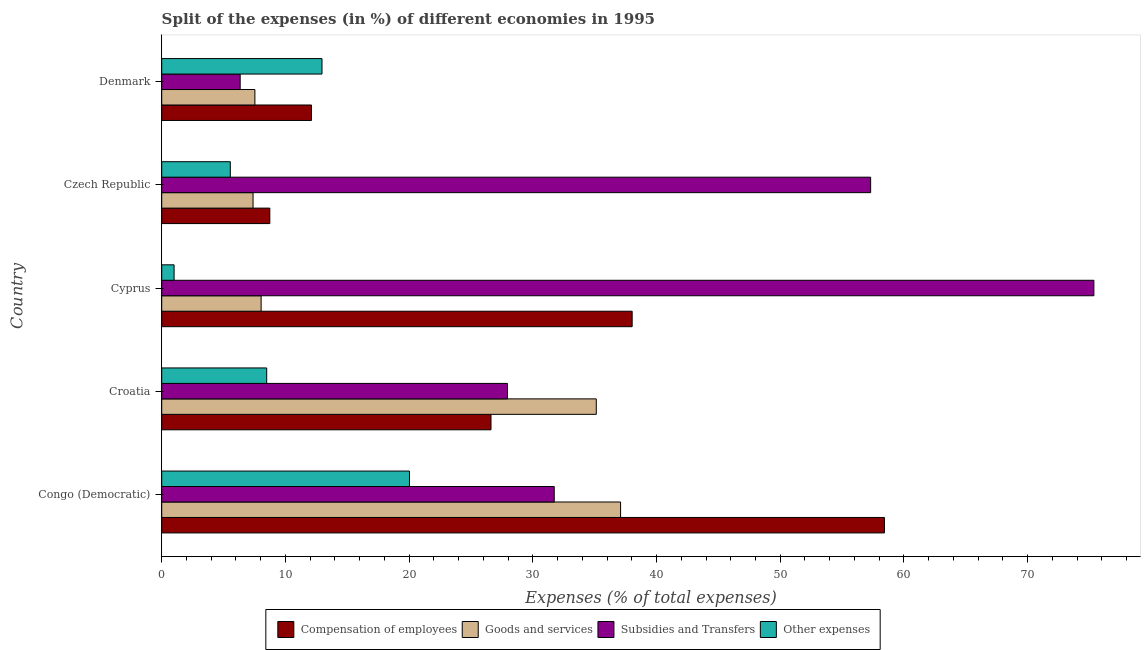How many groups of bars are there?
Your response must be concise. 5. Are the number of bars on each tick of the Y-axis equal?
Your answer should be very brief. Yes. How many bars are there on the 2nd tick from the top?
Keep it short and to the point. 4. How many bars are there on the 4th tick from the bottom?
Your answer should be compact. 4. What is the label of the 5th group of bars from the top?
Your response must be concise. Congo (Democratic). What is the percentage of amount spent on compensation of employees in Cyprus?
Provide a short and direct response. 38.03. Across all countries, what is the maximum percentage of amount spent on goods and services?
Make the answer very short. 37.09. Across all countries, what is the minimum percentage of amount spent on compensation of employees?
Give a very brief answer. 8.74. In which country was the percentage of amount spent on other expenses maximum?
Give a very brief answer. Congo (Democratic). In which country was the percentage of amount spent on subsidies minimum?
Offer a very short reply. Denmark. What is the total percentage of amount spent on goods and services in the graph?
Offer a terse response. 95.17. What is the difference between the percentage of amount spent on other expenses in Congo (Democratic) and that in Czech Republic?
Provide a succinct answer. 14.48. What is the difference between the percentage of amount spent on goods and services in Cyprus and the percentage of amount spent on other expenses in Denmark?
Give a very brief answer. -4.92. What is the average percentage of amount spent on other expenses per country?
Your response must be concise. 9.6. What is the difference between the percentage of amount spent on goods and services and percentage of amount spent on subsidies in Denmark?
Ensure brevity in your answer.  1.19. What is the ratio of the percentage of amount spent on subsidies in Cyprus to that in Czech Republic?
Offer a very short reply. 1.31. Is the percentage of amount spent on other expenses in Croatia less than that in Czech Republic?
Your answer should be very brief. No. Is the difference between the percentage of amount spent on subsidies in Congo (Democratic) and Denmark greater than the difference between the percentage of amount spent on goods and services in Congo (Democratic) and Denmark?
Give a very brief answer. No. What is the difference between the highest and the second highest percentage of amount spent on goods and services?
Provide a succinct answer. 1.97. What is the difference between the highest and the lowest percentage of amount spent on goods and services?
Ensure brevity in your answer.  29.71. In how many countries, is the percentage of amount spent on other expenses greater than the average percentage of amount spent on other expenses taken over all countries?
Make the answer very short. 2. Is the sum of the percentage of amount spent on other expenses in Croatia and Cyprus greater than the maximum percentage of amount spent on goods and services across all countries?
Provide a short and direct response. No. What does the 1st bar from the top in Czech Republic represents?
Make the answer very short. Other expenses. What does the 2nd bar from the bottom in Denmark represents?
Offer a terse response. Goods and services. Is it the case that in every country, the sum of the percentage of amount spent on compensation of employees and percentage of amount spent on goods and services is greater than the percentage of amount spent on subsidies?
Provide a short and direct response. No. How many bars are there?
Your response must be concise. 20. How many countries are there in the graph?
Provide a succinct answer. 5. What is the difference between two consecutive major ticks on the X-axis?
Keep it short and to the point. 10. Does the graph contain grids?
Keep it short and to the point. No. How many legend labels are there?
Your response must be concise. 4. How are the legend labels stacked?
Provide a short and direct response. Horizontal. What is the title of the graph?
Keep it short and to the point. Split of the expenses (in %) of different economies in 1995. What is the label or title of the X-axis?
Offer a terse response. Expenses (% of total expenses). What is the label or title of the Y-axis?
Keep it short and to the point. Country. What is the Expenses (% of total expenses) in Compensation of employees in Congo (Democratic)?
Provide a short and direct response. 58.42. What is the Expenses (% of total expenses) of Goods and services in Congo (Democratic)?
Give a very brief answer. 37.09. What is the Expenses (% of total expenses) in Subsidies and Transfers in Congo (Democratic)?
Your answer should be very brief. 31.73. What is the Expenses (% of total expenses) in Other expenses in Congo (Democratic)?
Keep it short and to the point. 20.03. What is the Expenses (% of total expenses) of Compensation of employees in Croatia?
Ensure brevity in your answer.  26.62. What is the Expenses (% of total expenses) of Goods and services in Croatia?
Your answer should be compact. 35.13. What is the Expenses (% of total expenses) of Subsidies and Transfers in Croatia?
Give a very brief answer. 27.95. What is the Expenses (% of total expenses) of Other expenses in Croatia?
Offer a very short reply. 8.49. What is the Expenses (% of total expenses) in Compensation of employees in Cyprus?
Your answer should be very brief. 38.03. What is the Expenses (% of total expenses) in Goods and services in Cyprus?
Your answer should be compact. 8.04. What is the Expenses (% of total expenses) of Subsidies and Transfers in Cyprus?
Your answer should be very brief. 75.35. What is the Expenses (% of total expenses) in Other expenses in Cyprus?
Make the answer very short. 1. What is the Expenses (% of total expenses) of Compensation of employees in Czech Republic?
Provide a short and direct response. 8.74. What is the Expenses (% of total expenses) of Goods and services in Czech Republic?
Give a very brief answer. 7.38. What is the Expenses (% of total expenses) of Subsidies and Transfers in Czech Republic?
Your answer should be compact. 57.31. What is the Expenses (% of total expenses) of Other expenses in Czech Republic?
Your answer should be compact. 5.55. What is the Expenses (% of total expenses) of Compensation of employees in Denmark?
Give a very brief answer. 12.11. What is the Expenses (% of total expenses) in Goods and services in Denmark?
Keep it short and to the point. 7.53. What is the Expenses (% of total expenses) in Subsidies and Transfers in Denmark?
Offer a terse response. 6.34. What is the Expenses (% of total expenses) in Other expenses in Denmark?
Give a very brief answer. 12.96. Across all countries, what is the maximum Expenses (% of total expenses) in Compensation of employees?
Give a very brief answer. 58.42. Across all countries, what is the maximum Expenses (% of total expenses) of Goods and services?
Offer a very short reply. 37.09. Across all countries, what is the maximum Expenses (% of total expenses) of Subsidies and Transfers?
Your answer should be very brief. 75.35. Across all countries, what is the maximum Expenses (% of total expenses) in Other expenses?
Offer a terse response. 20.03. Across all countries, what is the minimum Expenses (% of total expenses) in Compensation of employees?
Offer a very short reply. 8.74. Across all countries, what is the minimum Expenses (% of total expenses) in Goods and services?
Provide a succinct answer. 7.38. Across all countries, what is the minimum Expenses (% of total expenses) of Subsidies and Transfers?
Offer a terse response. 6.34. Across all countries, what is the minimum Expenses (% of total expenses) of Other expenses?
Your response must be concise. 1. What is the total Expenses (% of total expenses) of Compensation of employees in the graph?
Your answer should be very brief. 143.91. What is the total Expenses (% of total expenses) of Goods and services in the graph?
Ensure brevity in your answer.  95.17. What is the total Expenses (% of total expenses) in Subsidies and Transfers in the graph?
Your answer should be compact. 198.68. What is the total Expenses (% of total expenses) of Other expenses in the graph?
Give a very brief answer. 48.02. What is the difference between the Expenses (% of total expenses) in Compensation of employees in Congo (Democratic) and that in Croatia?
Offer a very short reply. 31.8. What is the difference between the Expenses (% of total expenses) of Goods and services in Congo (Democratic) and that in Croatia?
Make the answer very short. 1.96. What is the difference between the Expenses (% of total expenses) in Subsidies and Transfers in Congo (Democratic) and that in Croatia?
Make the answer very short. 3.78. What is the difference between the Expenses (% of total expenses) in Other expenses in Congo (Democratic) and that in Croatia?
Keep it short and to the point. 11.54. What is the difference between the Expenses (% of total expenses) in Compensation of employees in Congo (Democratic) and that in Cyprus?
Provide a short and direct response. 20.39. What is the difference between the Expenses (% of total expenses) of Goods and services in Congo (Democratic) and that in Cyprus?
Provide a succinct answer. 29.06. What is the difference between the Expenses (% of total expenses) of Subsidies and Transfers in Congo (Democratic) and that in Cyprus?
Your response must be concise. -43.62. What is the difference between the Expenses (% of total expenses) in Other expenses in Congo (Democratic) and that in Cyprus?
Provide a succinct answer. 19.03. What is the difference between the Expenses (% of total expenses) of Compensation of employees in Congo (Democratic) and that in Czech Republic?
Make the answer very short. 49.68. What is the difference between the Expenses (% of total expenses) of Goods and services in Congo (Democratic) and that in Czech Republic?
Make the answer very short. 29.71. What is the difference between the Expenses (% of total expenses) in Subsidies and Transfers in Congo (Democratic) and that in Czech Republic?
Your answer should be very brief. -25.58. What is the difference between the Expenses (% of total expenses) in Other expenses in Congo (Democratic) and that in Czech Republic?
Your answer should be very brief. 14.48. What is the difference between the Expenses (% of total expenses) in Compensation of employees in Congo (Democratic) and that in Denmark?
Provide a succinct answer. 46.31. What is the difference between the Expenses (% of total expenses) of Goods and services in Congo (Democratic) and that in Denmark?
Keep it short and to the point. 29.56. What is the difference between the Expenses (% of total expenses) in Subsidies and Transfers in Congo (Democratic) and that in Denmark?
Ensure brevity in your answer.  25.39. What is the difference between the Expenses (% of total expenses) in Other expenses in Congo (Democratic) and that in Denmark?
Your answer should be very brief. 7.07. What is the difference between the Expenses (% of total expenses) of Compensation of employees in Croatia and that in Cyprus?
Provide a short and direct response. -11.41. What is the difference between the Expenses (% of total expenses) of Goods and services in Croatia and that in Cyprus?
Your answer should be compact. 27.09. What is the difference between the Expenses (% of total expenses) of Subsidies and Transfers in Croatia and that in Cyprus?
Provide a short and direct response. -47.41. What is the difference between the Expenses (% of total expenses) in Other expenses in Croatia and that in Cyprus?
Provide a short and direct response. 7.49. What is the difference between the Expenses (% of total expenses) of Compensation of employees in Croatia and that in Czech Republic?
Keep it short and to the point. 17.88. What is the difference between the Expenses (% of total expenses) in Goods and services in Croatia and that in Czech Republic?
Offer a very short reply. 27.74. What is the difference between the Expenses (% of total expenses) in Subsidies and Transfers in Croatia and that in Czech Republic?
Provide a succinct answer. -29.36. What is the difference between the Expenses (% of total expenses) of Other expenses in Croatia and that in Czech Republic?
Provide a short and direct response. 2.94. What is the difference between the Expenses (% of total expenses) of Compensation of employees in Croatia and that in Denmark?
Offer a very short reply. 14.51. What is the difference between the Expenses (% of total expenses) in Goods and services in Croatia and that in Denmark?
Provide a short and direct response. 27.6. What is the difference between the Expenses (% of total expenses) of Subsidies and Transfers in Croatia and that in Denmark?
Offer a terse response. 21.61. What is the difference between the Expenses (% of total expenses) in Other expenses in Croatia and that in Denmark?
Give a very brief answer. -4.47. What is the difference between the Expenses (% of total expenses) of Compensation of employees in Cyprus and that in Czech Republic?
Your answer should be compact. 29.29. What is the difference between the Expenses (% of total expenses) of Goods and services in Cyprus and that in Czech Republic?
Provide a succinct answer. 0.65. What is the difference between the Expenses (% of total expenses) in Subsidies and Transfers in Cyprus and that in Czech Republic?
Offer a very short reply. 18.05. What is the difference between the Expenses (% of total expenses) of Other expenses in Cyprus and that in Czech Republic?
Give a very brief answer. -4.54. What is the difference between the Expenses (% of total expenses) in Compensation of employees in Cyprus and that in Denmark?
Your answer should be very brief. 25.92. What is the difference between the Expenses (% of total expenses) in Goods and services in Cyprus and that in Denmark?
Give a very brief answer. 0.5. What is the difference between the Expenses (% of total expenses) in Subsidies and Transfers in Cyprus and that in Denmark?
Make the answer very short. 69.01. What is the difference between the Expenses (% of total expenses) of Other expenses in Cyprus and that in Denmark?
Provide a succinct answer. -11.96. What is the difference between the Expenses (% of total expenses) of Compensation of employees in Czech Republic and that in Denmark?
Ensure brevity in your answer.  -3.37. What is the difference between the Expenses (% of total expenses) in Goods and services in Czech Republic and that in Denmark?
Your answer should be compact. -0.15. What is the difference between the Expenses (% of total expenses) of Subsidies and Transfers in Czech Republic and that in Denmark?
Give a very brief answer. 50.97. What is the difference between the Expenses (% of total expenses) of Other expenses in Czech Republic and that in Denmark?
Make the answer very short. -7.41. What is the difference between the Expenses (% of total expenses) of Compensation of employees in Congo (Democratic) and the Expenses (% of total expenses) of Goods and services in Croatia?
Offer a very short reply. 23.29. What is the difference between the Expenses (% of total expenses) of Compensation of employees in Congo (Democratic) and the Expenses (% of total expenses) of Subsidies and Transfers in Croatia?
Keep it short and to the point. 30.47. What is the difference between the Expenses (% of total expenses) in Compensation of employees in Congo (Democratic) and the Expenses (% of total expenses) in Other expenses in Croatia?
Your response must be concise. 49.93. What is the difference between the Expenses (% of total expenses) in Goods and services in Congo (Democratic) and the Expenses (% of total expenses) in Subsidies and Transfers in Croatia?
Provide a short and direct response. 9.14. What is the difference between the Expenses (% of total expenses) of Goods and services in Congo (Democratic) and the Expenses (% of total expenses) of Other expenses in Croatia?
Make the answer very short. 28.61. What is the difference between the Expenses (% of total expenses) of Subsidies and Transfers in Congo (Democratic) and the Expenses (% of total expenses) of Other expenses in Croatia?
Provide a short and direct response. 23.24. What is the difference between the Expenses (% of total expenses) in Compensation of employees in Congo (Democratic) and the Expenses (% of total expenses) in Goods and services in Cyprus?
Offer a very short reply. 50.38. What is the difference between the Expenses (% of total expenses) in Compensation of employees in Congo (Democratic) and the Expenses (% of total expenses) in Subsidies and Transfers in Cyprus?
Make the answer very short. -16.93. What is the difference between the Expenses (% of total expenses) of Compensation of employees in Congo (Democratic) and the Expenses (% of total expenses) of Other expenses in Cyprus?
Your response must be concise. 57.42. What is the difference between the Expenses (% of total expenses) of Goods and services in Congo (Democratic) and the Expenses (% of total expenses) of Subsidies and Transfers in Cyprus?
Provide a succinct answer. -38.26. What is the difference between the Expenses (% of total expenses) of Goods and services in Congo (Democratic) and the Expenses (% of total expenses) of Other expenses in Cyprus?
Give a very brief answer. 36.09. What is the difference between the Expenses (% of total expenses) in Subsidies and Transfers in Congo (Democratic) and the Expenses (% of total expenses) in Other expenses in Cyprus?
Provide a short and direct response. 30.73. What is the difference between the Expenses (% of total expenses) in Compensation of employees in Congo (Democratic) and the Expenses (% of total expenses) in Goods and services in Czech Republic?
Provide a succinct answer. 51.04. What is the difference between the Expenses (% of total expenses) of Compensation of employees in Congo (Democratic) and the Expenses (% of total expenses) of Subsidies and Transfers in Czech Republic?
Keep it short and to the point. 1.11. What is the difference between the Expenses (% of total expenses) in Compensation of employees in Congo (Democratic) and the Expenses (% of total expenses) in Other expenses in Czech Republic?
Your response must be concise. 52.87. What is the difference between the Expenses (% of total expenses) in Goods and services in Congo (Democratic) and the Expenses (% of total expenses) in Subsidies and Transfers in Czech Republic?
Offer a very short reply. -20.21. What is the difference between the Expenses (% of total expenses) in Goods and services in Congo (Democratic) and the Expenses (% of total expenses) in Other expenses in Czech Republic?
Provide a succinct answer. 31.55. What is the difference between the Expenses (% of total expenses) of Subsidies and Transfers in Congo (Democratic) and the Expenses (% of total expenses) of Other expenses in Czech Republic?
Offer a terse response. 26.18. What is the difference between the Expenses (% of total expenses) of Compensation of employees in Congo (Democratic) and the Expenses (% of total expenses) of Goods and services in Denmark?
Provide a short and direct response. 50.89. What is the difference between the Expenses (% of total expenses) of Compensation of employees in Congo (Democratic) and the Expenses (% of total expenses) of Subsidies and Transfers in Denmark?
Keep it short and to the point. 52.08. What is the difference between the Expenses (% of total expenses) of Compensation of employees in Congo (Democratic) and the Expenses (% of total expenses) of Other expenses in Denmark?
Your response must be concise. 45.46. What is the difference between the Expenses (% of total expenses) in Goods and services in Congo (Democratic) and the Expenses (% of total expenses) in Subsidies and Transfers in Denmark?
Your answer should be very brief. 30.75. What is the difference between the Expenses (% of total expenses) in Goods and services in Congo (Democratic) and the Expenses (% of total expenses) in Other expenses in Denmark?
Ensure brevity in your answer.  24.14. What is the difference between the Expenses (% of total expenses) in Subsidies and Transfers in Congo (Democratic) and the Expenses (% of total expenses) in Other expenses in Denmark?
Give a very brief answer. 18.77. What is the difference between the Expenses (% of total expenses) in Compensation of employees in Croatia and the Expenses (% of total expenses) in Goods and services in Cyprus?
Make the answer very short. 18.58. What is the difference between the Expenses (% of total expenses) in Compensation of employees in Croatia and the Expenses (% of total expenses) in Subsidies and Transfers in Cyprus?
Offer a terse response. -48.73. What is the difference between the Expenses (% of total expenses) of Compensation of employees in Croatia and the Expenses (% of total expenses) of Other expenses in Cyprus?
Keep it short and to the point. 25.62. What is the difference between the Expenses (% of total expenses) of Goods and services in Croatia and the Expenses (% of total expenses) of Subsidies and Transfers in Cyprus?
Provide a short and direct response. -40.22. What is the difference between the Expenses (% of total expenses) of Goods and services in Croatia and the Expenses (% of total expenses) of Other expenses in Cyprus?
Provide a short and direct response. 34.13. What is the difference between the Expenses (% of total expenses) of Subsidies and Transfers in Croatia and the Expenses (% of total expenses) of Other expenses in Cyprus?
Your answer should be very brief. 26.95. What is the difference between the Expenses (% of total expenses) of Compensation of employees in Croatia and the Expenses (% of total expenses) of Goods and services in Czech Republic?
Provide a short and direct response. 19.23. What is the difference between the Expenses (% of total expenses) of Compensation of employees in Croatia and the Expenses (% of total expenses) of Subsidies and Transfers in Czech Republic?
Ensure brevity in your answer.  -30.69. What is the difference between the Expenses (% of total expenses) in Compensation of employees in Croatia and the Expenses (% of total expenses) in Other expenses in Czech Republic?
Make the answer very short. 21.07. What is the difference between the Expenses (% of total expenses) in Goods and services in Croatia and the Expenses (% of total expenses) in Subsidies and Transfers in Czech Republic?
Provide a short and direct response. -22.18. What is the difference between the Expenses (% of total expenses) of Goods and services in Croatia and the Expenses (% of total expenses) of Other expenses in Czech Republic?
Your answer should be compact. 29.58. What is the difference between the Expenses (% of total expenses) of Subsidies and Transfers in Croatia and the Expenses (% of total expenses) of Other expenses in Czech Republic?
Provide a short and direct response. 22.4. What is the difference between the Expenses (% of total expenses) in Compensation of employees in Croatia and the Expenses (% of total expenses) in Goods and services in Denmark?
Make the answer very short. 19.09. What is the difference between the Expenses (% of total expenses) of Compensation of employees in Croatia and the Expenses (% of total expenses) of Subsidies and Transfers in Denmark?
Provide a succinct answer. 20.28. What is the difference between the Expenses (% of total expenses) of Compensation of employees in Croatia and the Expenses (% of total expenses) of Other expenses in Denmark?
Your answer should be compact. 13.66. What is the difference between the Expenses (% of total expenses) of Goods and services in Croatia and the Expenses (% of total expenses) of Subsidies and Transfers in Denmark?
Offer a very short reply. 28.79. What is the difference between the Expenses (% of total expenses) of Goods and services in Croatia and the Expenses (% of total expenses) of Other expenses in Denmark?
Offer a very short reply. 22.17. What is the difference between the Expenses (% of total expenses) in Subsidies and Transfers in Croatia and the Expenses (% of total expenses) in Other expenses in Denmark?
Provide a short and direct response. 14.99. What is the difference between the Expenses (% of total expenses) of Compensation of employees in Cyprus and the Expenses (% of total expenses) of Goods and services in Czech Republic?
Provide a short and direct response. 30.65. What is the difference between the Expenses (% of total expenses) in Compensation of employees in Cyprus and the Expenses (% of total expenses) in Subsidies and Transfers in Czech Republic?
Your answer should be compact. -19.28. What is the difference between the Expenses (% of total expenses) of Compensation of employees in Cyprus and the Expenses (% of total expenses) of Other expenses in Czech Republic?
Keep it short and to the point. 32.48. What is the difference between the Expenses (% of total expenses) of Goods and services in Cyprus and the Expenses (% of total expenses) of Subsidies and Transfers in Czech Republic?
Your answer should be very brief. -49.27. What is the difference between the Expenses (% of total expenses) of Goods and services in Cyprus and the Expenses (% of total expenses) of Other expenses in Czech Republic?
Your answer should be very brief. 2.49. What is the difference between the Expenses (% of total expenses) in Subsidies and Transfers in Cyprus and the Expenses (% of total expenses) in Other expenses in Czech Republic?
Provide a succinct answer. 69.81. What is the difference between the Expenses (% of total expenses) in Compensation of employees in Cyprus and the Expenses (% of total expenses) in Goods and services in Denmark?
Your answer should be compact. 30.5. What is the difference between the Expenses (% of total expenses) of Compensation of employees in Cyprus and the Expenses (% of total expenses) of Subsidies and Transfers in Denmark?
Give a very brief answer. 31.69. What is the difference between the Expenses (% of total expenses) of Compensation of employees in Cyprus and the Expenses (% of total expenses) of Other expenses in Denmark?
Give a very brief answer. 25.07. What is the difference between the Expenses (% of total expenses) in Goods and services in Cyprus and the Expenses (% of total expenses) in Subsidies and Transfers in Denmark?
Offer a very short reply. 1.69. What is the difference between the Expenses (% of total expenses) of Goods and services in Cyprus and the Expenses (% of total expenses) of Other expenses in Denmark?
Your answer should be compact. -4.92. What is the difference between the Expenses (% of total expenses) of Subsidies and Transfers in Cyprus and the Expenses (% of total expenses) of Other expenses in Denmark?
Your answer should be compact. 62.4. What is the difference between the Expenses (% of total expenses) of Compensation of employees in Czech Republic and the Expenses (% of total expenses) of Goods and services in Denmark?
Give a very brief answer. 1.21. What is the difference between the Expenses (% of total expenses) in Compensation of employees in Czech Republic and the Expenses (% of total expenses) in Subsidies and Transfers in Denmark?
Your response must be concise. 2.4. What is the difference between the Expenses (% of total expenses) in Compensation of employees in Czech Republic and the Expenses (% of total expenses) in Other expenses in Denmark?
Offer a very short reply. -4.22. What is the difference between the Expenses (% of total expenses) of Goods and services in Czech Republic and the Expenses (% of total expenses) of Subsidies and Transfers in Denmark?
Offer a very short reply. 1.04. What is the difference between the Expenses (% of total expenses) in Goods and services in Czech Republic and the Expenses (% of total expenses) in Other expenses in Denmark?
Provide a succinct answer. -5.57. What is the difference between the Expenses (% of total expenses) of Subsidies and Transfers in Czech Republic and the Expenses (% of total expenses) of Other expenses in Denmark?
Offer a very short reply. 44.35. What is the average Expenses (% of total expenses) in Compensation of employees per country?
Make the answer very short. 28.78. What is the average Expenses (% of total expenses) in Goods and services per country?
Give a very brief answer. 19.03. What is the average Expenses (% of total expenses) of Subsidies and Transfers per country?
Ensure brevity in your answer.  39.74. What is the average Expenses (% of total expenses) of Other expenses per country?
Offer a very short reply. 9.6. What is the difference between the Expenses (% of total expenses) of Compensation of employees and Expenses (% of total expenses) of Goods and services in Congo (Democratic)?
Your response must be concise. 21.33. What is the difference between the Expenses (% of total expenses) of Compensation of employees and Expenses (% of total expenses) of Subsidies and Transfers in Congo (Democratic)?
Give a very brief answer. 26.69. What is the difference between the Expenses (% of total expenses) in Compensation of employees and Expenses (% of total expenses) in Other expenses in Congo (Democratic)?
Provide a succinct answer. 38.39. What is the difference between the Expenses (% of total expenses) in Goods and services and Expenses (% of total expenses) in Subsidies and Transfers in Congo (Democratic)?
Give a very brief answer. 5.36. What is the difference between the Expenses (% of total expenses) of Goods and services and Expenses (% of total expenses) of Other expenses in Congo (Democratic)?
Offer a terse response. 17.07. What is the difference between the Expenses (% of total expenses) of Subsidies and Transfers and Expenses (% of total expenses) of Other expenses in Congo (Democratic)?
Provide a short and direct response. 11.7. What is the difference between the Expenses (% of total expenses) in Compensation of employees and Expenses (% of total expenses) in Goods and services in Croatia?
Provide a short and direct response. -8.51. What is the difference between the Expenses (% of total expenses) in Compensation of employees and Expenses (% of total expenses) in Subsidies and Transfers in Croatia?
Ensure brevity in your answer.  -1.33. What is the difference between the Expenses (% of total expenses) in Compensation of employees and Expenses (% of total expenses) in Other expenses in Croatia?
Keep it short and to the point. 18.13. What is the difference between the Expenses (% of total expenses) of Goods and services and Expenses (% of total expenses) of Subsidies and Transfers in Croatia?
Provide a succinct answer. 7.18. What is the difference between the Expenses (% of total expenses) of Goods and services and Expenses (% of total expenses) of Other expenses in Croatia?
Provide a short and direct response. 26.64. What is the difference between the Expenses (% of total expenses) of Subsidies and Transfers and Expenses (% of total expenses) of Other expenses in Croatia?
Your answer should be compact. 19.46. What is the difference between the Expenses (% of total expenses) of Compensation of employees and Expenses (% of total expenses) of Goods and services in Cyprus?
Provide a succinct answer. 29.99. What is the difference between the Expenses (% of total expenses) in Compensation of employees and Expenses (% of total expenses) in Subsidies and Transfers in Cyprus?
Offer a terse response. -37.32. What is the difference between the Expenses (% of total expenses) of Compensation of employees and Expenses (% of total expenses) of Other expenses in Cyprus?
Give a very brief answer. 37.03. What is the difference between the Expenses (% of total expenses) of Goods and services and Expenses (% of total expenses) of Subsidies and Transfers in Cyprus?
Give a very brief answer. -67.32. What is the difference between the Expenses (% of total expenses) of Goods and services and Expenses (% of total expenses) of Other expenses in Cyprus?
Your answer should be compact. 7.03. What is the difference between the Expenses (% of total expenses) of Subsidies and Transfers and Expenses (% of total expenses) of Other expenses in Cyprus?
Keep it short and to the point. 74.35. What is the difference between the Expenses (% of total expenses) in Compensation of employees and Expenses (% of total expenses) in Goods and services in Czech Republic?
Your answer should be very brief. 1.35. What is the difference between the Expenses (% of total expenses) of Compensation of employees and Expenses (% of total expenses) of Subsidies and Transfers in Czech Republic?
Your response must be concise. -48.57. What is the difference between the Expenses (% of total expenses) of Compensation of employees and Expenses (% of total expenses) of Other expenses in Czech Republic?
Provide a succinct answer. 3.19. What is the difference between the Expenses (% of total expenses) in Goods and services and Expenses (% of total expenses) in Subsidies and Transfers in Czech Republic?
Offer a terse response. -49.92. What is the difference between the Expenses (% of total expenses) in Goods and services and Expenses (% of total expenses) in Other expenses in Czech Republic?
Provide a succinct answer. 1.84. What is the difference between the Expenses (% of total expenses) of Subsidies and Transfers and Expenses (% of total expenses) of Other expenses in Czech Republic?
Your answer should be compact. 51.76. What is the difference between the Expenses (% of total expenses) of Compensation of employees and Expenses (% of total expenses) of Goods and services in Denmark?
Provide a succinct answer. 4.58. What is the difference between the Expenses (% of total expenses) of Compensation of employees and Expenses (% of total expenses) of Subsidies and Transfers in Denmark?
Offer a very short reply. 5.76. What is the difference between the Expenses (% of total expenses) in Compensation of employees and Expenses (% of total expenses) in Other expenses in Denmark?
Your answer should be very brief. -0.85. What is the difference between the Expenses (% of total expenses) of Goods and services and Expenses (% of total expenses) of Subsidies and Transfers in Denmark?
Provide a succinct answer. 1.19. What is the difference between the Expenses (% of total expenses) in Goods and services and Expenses (% of total expenses) in Other expenses in Denmark?
Provide a short and direct response. -5.43. What is the difference between the Expenses (% of total expenses) in Subsidies and Transfers and Expenses (% of total expenses) in Other expenses in Denmark?
Provide a short and direct response. -6.61. What is the ratio of the Expenses (% of total expenses) in Compensation of employees in Congo (Democratic) to that in Croatia?
Offer a terse response. 2.19. What is the ratio of the Expenses (% of total expenses) of Goods and services in Congo (Democratic) to that in Croatia?
Ensure brevity in your answer.  1.06. What is the ratio of the Expenses (% of total expenses) in Subsidies and Transfers in Congo (Democratic) to that in Croatia?
Ensure brevity in your answer.  1.14. What is the ratio of the Expenses (% of total expenses) in Other expenses in Congo (Democratic) to that in Croatia?
Provide a short and direct response. 2.36. What is the ratio of the Expenses (% of total expenses) in Compensation of employees in Congo (Democratic) to that in Cyprus?
Keep it short and to the point. 1.54. What is the ratio of the Expenses (% of total expenses) of Goods and services in Congo (Democratic) to that in Cyprus?
Your response must be concise. 4.62. What is the ratio of the Expenses (% of total expenses) of Subsidies and Transfers in Congo (Democratic) to that in Cyprus?
Offer a very short reply. 0.42. What is the ratio of the Expenses (% of total expenses) in Other expenses in Congo (Democratic) to that in Cyprus?
Your answer should be compact. 20.01. What is the ratio of the Expenses (% of total expenses) in Compensation of employees in Congo (Democratic) to that in Czech Republic?
Provide a short and direct response. 6.69. What is the ratio of the Expenses (% of total expenses) of Goods and services in Congo (Democratic) to that in Czech Republic?
Provide a short and direct response. 5.02. What is the ratio of the Expenses (% of total expenses) of Subsidies and Transfers in Congo (Democratic) to that in Czech Republic?
Provide a short and direct response. 0.55. What is the ratio of the Expenses (% of total expenses) in Other expenses in Congo (Democratic) to that in Czech Republic?
Give a very brief answer. 3.61. What is the ratio of the Expenses (% of total expenses) of Compensation of employees in Congo (Democratic) to that in Denmark?
Your answer should be very brief. 4.83. What is the ratio of the Expenses (% of total expenses) in Goods and services in Congo (Democratic) to that in Denmark?
Provide a short and direct response. 4.92. What is the ratio of the Expenses (% of total expenses) of Subsidies and Transfers in Congo (Democratic) to that in Denmark?
Your answer should be very brief. 5. What is the ratio of the Expenses (% of total expenses) in Other expenses in Congo (Democratic) to that in Denmark?
Provide a short and direct response. 1.55. What is the ratio of the Expenses (% of total expenses) in Compensation of employees in Croatia to that in Cyprus?
Provide a short and direct response. 0.7. What is the ratio of the Expenses (% of total expenses) of Goods and services in Croatia to that in Cyprus?
Provide a short and direct response. 4.37. What is the ratio of the Expenses (% of total expenses) in Subsidies and Transfers in Croatia to that in Cyprus?
Offer a very short reply. 0.37. What is the ratio of the Expenses (% of total expenses) in Other expenses in Croatia to that in Cyprus?
Your response must be concise. 8.48. What is the ratio of the Expenses (% of total expenses) of Compensation of employees in Croatia to that in Czech Republic?
Your answer should be very brief. 3.05. What is the ratio of the Expenses (% of total expenses) in Goods and services in Croatia to that in Czech Republic?
Offer a very short reply. 4.76. What is the ratio of the Expenses (% of total expenses) of Subsidies and Transfers in Croatia to that in Czech Republic?
Provide a short and direct response. 0.49. What is the ratio of the Expenses (% of total expenses) of Other expenses in Croatia to that in Czech Republic?
Provide a short and direct response. 1.53. What is the ratio of the Expenses (% of total expenses) in Compensation of employees in Croatia to that in Denmark?
Ensure brevity in your answer.  2.2. What is the ratio of the Expenses (% of total expenses) in Goods and services in Croatia to that in Denmark?
Provide a short and direct response. 4.66. What is the ratio of the Expenses (% of total expenses) of Subsidies and Transfers in Croatia to that in Denmark?
Keep it short and to the point. 4.41. What is the ratio of the Expenses (% of total expenses) in Other expenses in Croatia to that in Denmark?
Your answer should be very brief. 0.66. What is the ratio of the Expenses (% of total expenses) in Compensation of employees in Cyprus to that in Czech Republic?
Ensure brevity in your answer.  4.35. What is the ratio of the Expenses (% of total expenses) in Goods and services in Cyprus to that in Czech Republic?
Your response must be concise. 1.09. What is the ratio of the Expenses (% of total expenses) in Subsidies and Transfers in Cyprus to that in Czech Republic?
Offer a terse response. 1.31. What is the ratio of the Expenses (% of total expenses) in Other expenses in Cyprus to that in Czech Republic?
Offer a terse response. 0.18. What is the ratio of the Expenses (% of total expenses) in Compensation of employees in Cyprus to that in Denmark?
Your answer should be compact. 3.14. What is the ratio of the Expenses (% of total expenses) in Goods and services in Cyprus to that in Denmark?
Your answer should be compact. 1.07. What is the ratio of the Expenses (% of total expenses) in Subsidies and Transfers in Cyprus to that in Denmark?
Ensure brevity in your answer.  11.88. What is the ratio of the Expenses (% of total expenses) of Other expenses in Cyprus to that in Denmark?
Keep it short and to the point. 0.08. What is the ratio of the Expenses (% of total expenses) of Compensation of employees in Czech Republic to that in Denmark?
Provide a succinct answer. 0.72. What is the ratio of the Expenses (% of total expenses) in Goods and services in Czech Republic to that in Denmark?
Your response must be concise. 0.98. What is the ratio of the Expenses (% of total expenses) of Subsidies and Transfers in Czech Republic to that in Denmark?
Your answer should be compact. 9.04. What is the ratio of the Expenses (% of total expenses) in Other expenses in Czech Republic to that in Denmark?
Keep it short and to the point. 0.43. What is the difference between the highest and the second highest Expenses (% of total expenses) of Compensation of employees?
Your answer should be very brief. 20.39. What is the difference between the highest and the second highest Expenses (% of total expenses) of Goods and services?
Give a very brief answer. 1.96. What is the difference between the highest and the second highest Expenses (% of total expenses) in Subsidies and Transfers?
Give a very brief answer. 18.05. What is the difference between the highest and the second highest Expenses (% of total expenses) of Other expenses?
Offer a terse response. 7.07. What is the difference between the highest and the lowest Expenses (% of total expenses) of Compensation of employees?
Ensure brevity in your answer.  49.68. What is the difference between the highest and the lowest Expenses (% of total expenses) of Goods and services?
Keep it short and to the point. 29.71. What is the difference between the highest and the lowest Expenses (% of total expenses) in Subsidies and Transfers?
Make the answer very short. 69.01. What is the difference between the highest and the lowest Expenses (% of total expenses) of Other expenses?
Offer a very short reply. 19.03. 